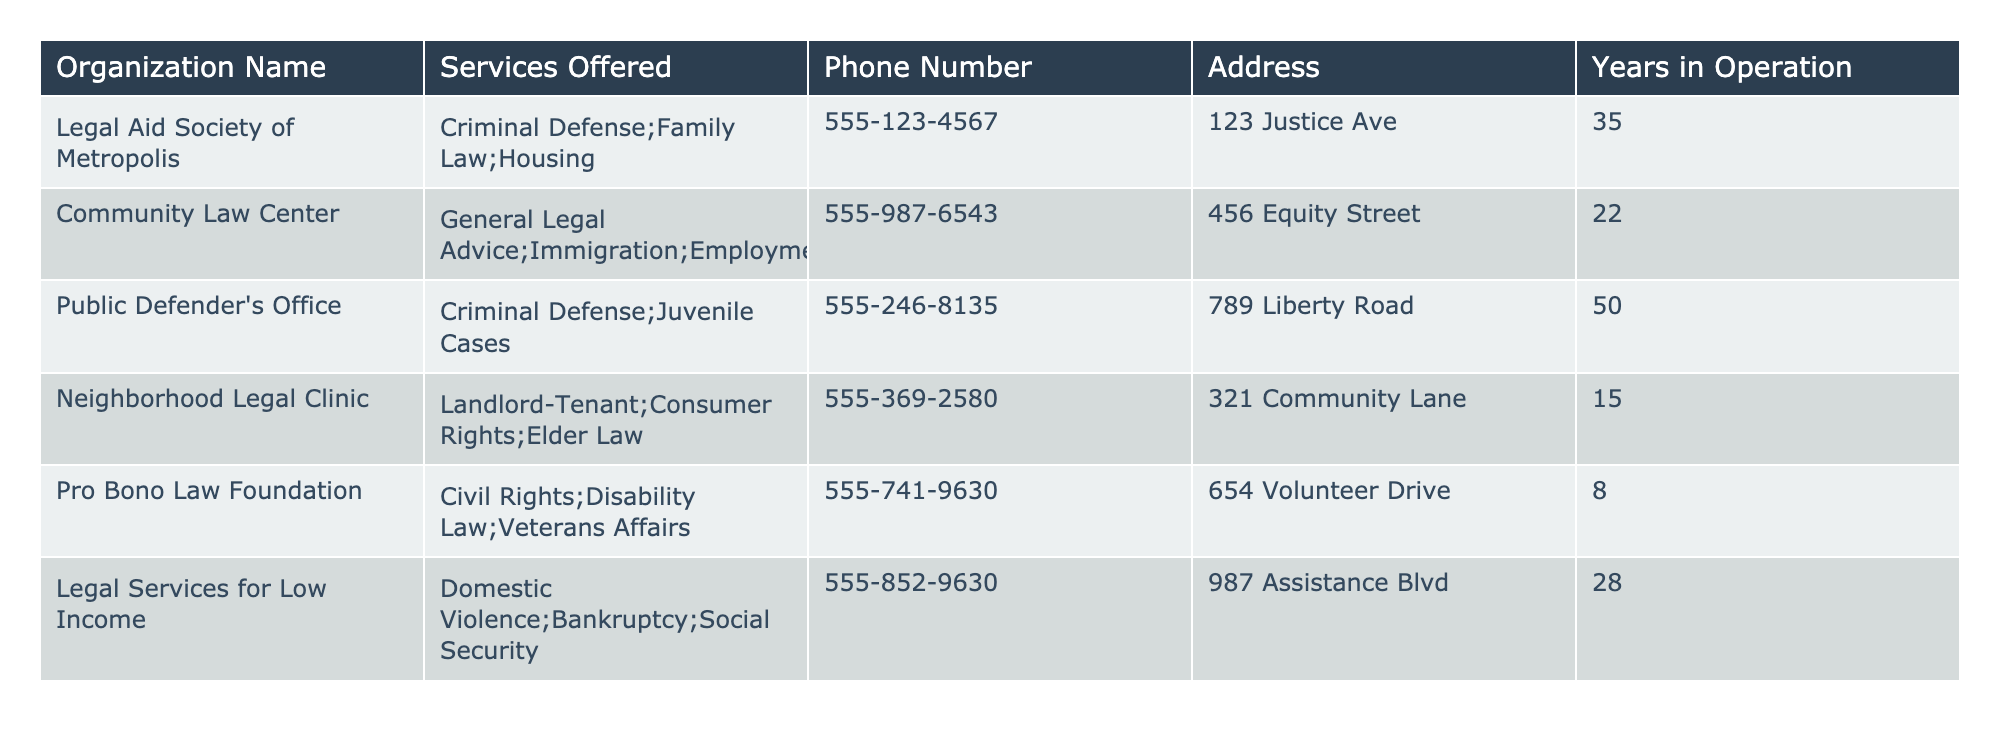What services does the Public Defender's Office provide? The table lists the Public Defender's Office under "Services Offered" as providing Criminal Defense and Juvenile Cases.
Answer: Criminal Defense; Juvenile Cases How many years has the Neighborhood Legal Clinic been in operation? According to the table, the Neighborhood Legal Clinic has been in operation for 15 years.
Answer: 15 Which organization offers services related to Veterans Affairs? The Pro Bono Law Foundation offers services related to Veterans Affairs, as noted in the "Services Offered" column.
Answer: Pro Bono Law Foundation What is the difference in years of operation between the Legal Aid Society of Metropolis and the Pro Bono Law Foundation? The Legal Aid Society of Metropolis operates for 35 years, while the Pro Bono Law Foundation operates for 8 years. The difference is 35 - 8 = 27 years.
Answer: 27 Is there an organization that provides both Family Law and Immigration services? No, the Legal Aid Society of Metropolis offers Family Law, and the Community Law Center offers Immigration services, but no single organization provides both.
Answer: No Which organization has the longest time in operation? The Public Defender's Office has been in operation for 50 years, which is longer than any other listed organization.
Answer: Public Defender's Office What is the total number of years of operation across all organizations listed in the table? Adding the years in operation for each organization: 35 + 22 + 50 + 15 + 8 + 28 = 158 years total.
Answer: 158 Can you identify an organization that focuses on Elder Law? Yes, the Neighborhood Legal Clinic specializes in Elder Law as indicated in the "Services Offered" column.
Answer: Neighborhood Legal Clinic Which organization has the shortest duration of operation? The Pro Bono Law Foundation has the shortest duration of operation at 8 years.
Answer: Pro Bono Law Foundation 